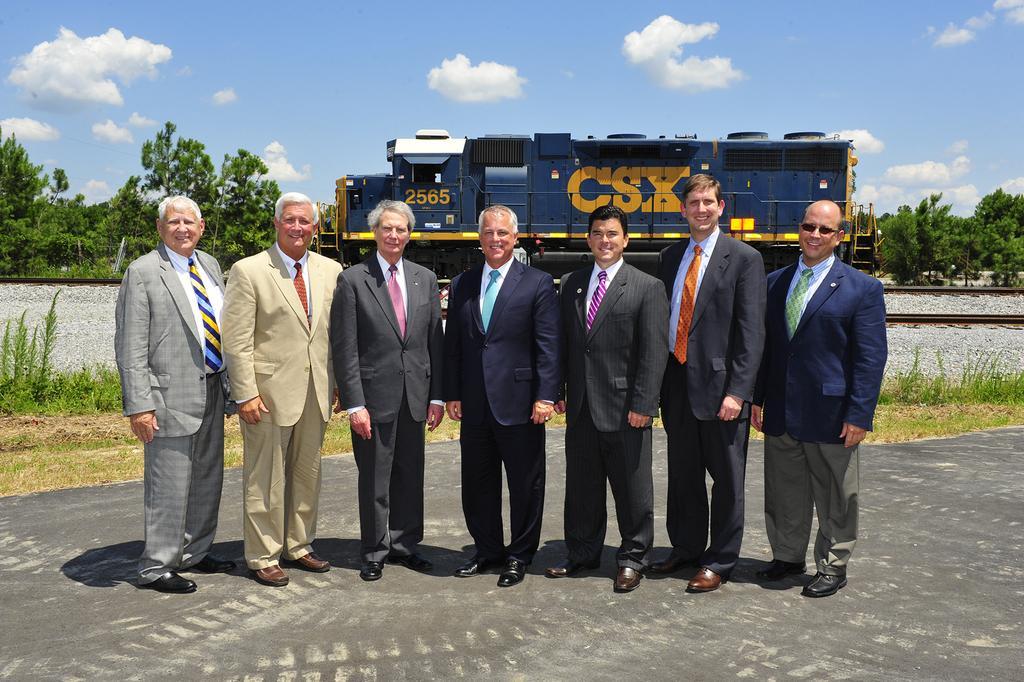Could you give a brief overview of what you see in this image? In this image we can see group persons standing on the ground. One person is wearing a blue coat with green tie and goggles is standing to the right side of the image. In the background we can see a train standing on the track ,group of trees and a cloudy sky. 